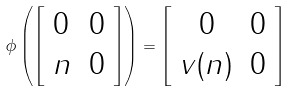Convert formula to latex. <formula><loc_0><loc_0><loc_500><loc_500>\phi \left ( \left [ \begin{array} { l l } 0 & 0 \\ n & 0 \end{array} \right ] \right ) = \left [ \begin{array} { c c } 0 & 0 \\ v ( n ) & 0 \end{array} \right ]</formula> 